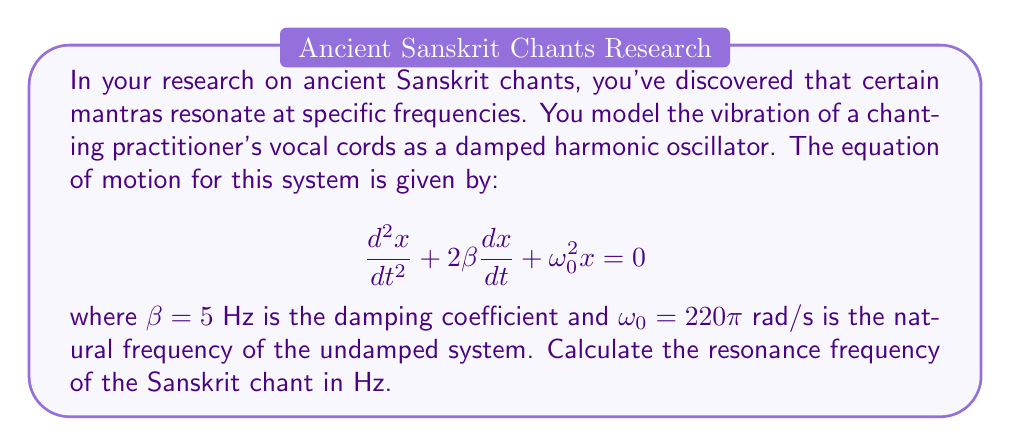Could you help me with this problem? To solve this problem, we need to follow these steps:

1) The general form of a damped harmonic oscillator equation is:

   $$\frac{d^2x}{dt^2} + 2\beta\frac{dx}{dt} + \omega_0^2x = 0$$

   where $\beta$ is the damping coefficient and $\omega_0$ is the natural frequency of the undamped system.

2) The resonance frequency $\omega_r$ for a damped system is given by:

   $$\omega_r = \sqrt{\omega_0^2 - 2\beta^2}$$

3) We are given:
   $\beta = 5$ Hz
   $\omega_0 = 220\pi$ rad/s

4) Let's substitute these values into the formula:

   $$\omega_r = \sqrt{(220\pi)^2 - 2(5)^2}$$

5) Simplify:
   $$\omega_r = \sqrt{48400\pi^2 - 50}$$
   $$\omega_r = \sqrt{477128.77}$$
   $$\omega_r \approx 690.74$$ rad/s

6) To convert from rad/s to Hz, we divide by $2\pi$:

   $$f_r = \frac{\omega_r}{2\pi} = \frac{690.74}{2\pi} \approx 109.94$$ Hz

Therefore, the resonance frequency of the Sanskrit chant is approximately 109.94 Hz.
Answer: 109.94 Hz 